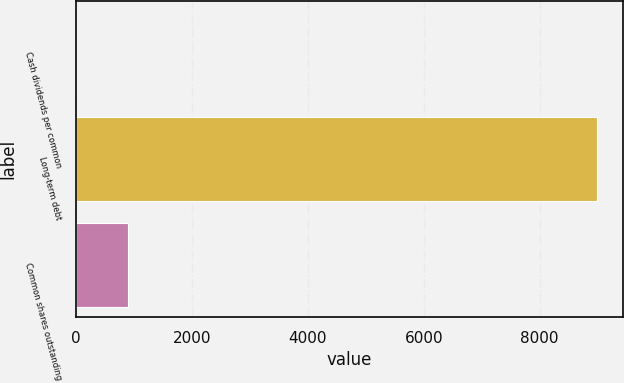<chart> <loc_0><loc_0><loc_500><loc_500><bar_chart><fcel>Cash dividends per common<fcel>Long-term debt<fcel>Common shares outstanding<nl><fcel>0.96<fcel>8990<fcel>899.86<nl></chart> 